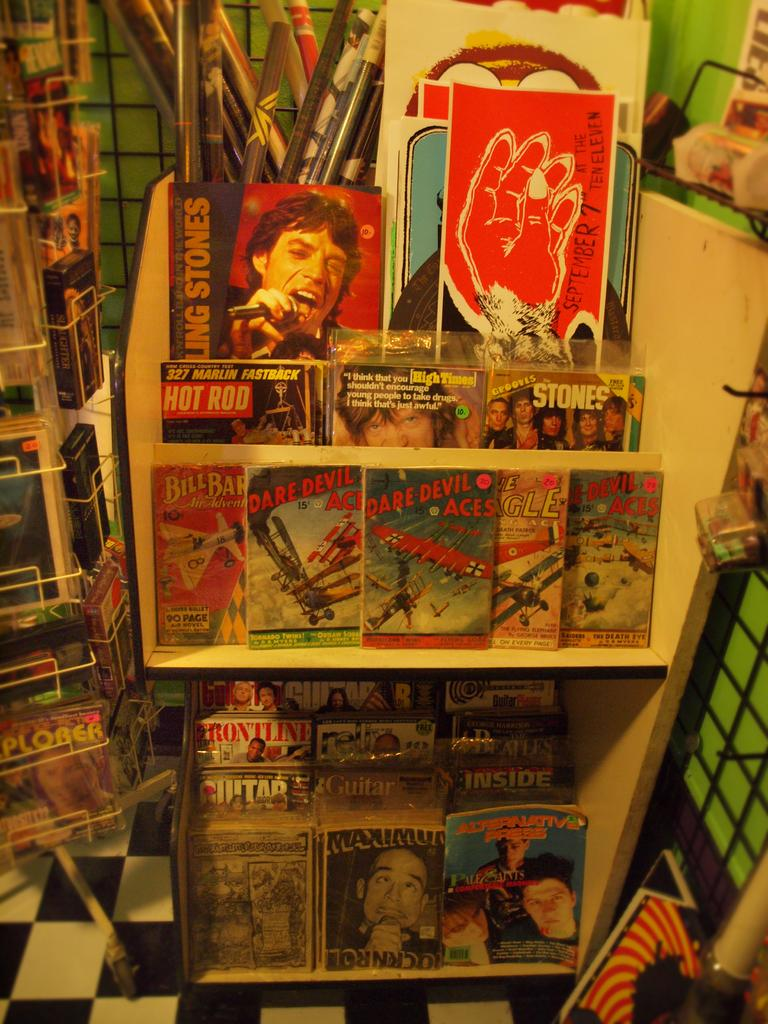<image>
Describe the image concisely. Shelves hold a lot of books and magazines and one has the word stones on it with a picture of Mick Jagger. 